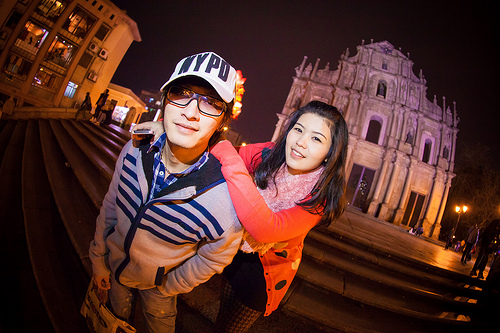<image>
Can you confirm if the hat is on the woman? No. The hat is not positioned on the woman. They may be near each other, but the hat is not supported by or resting on top of the woman. 